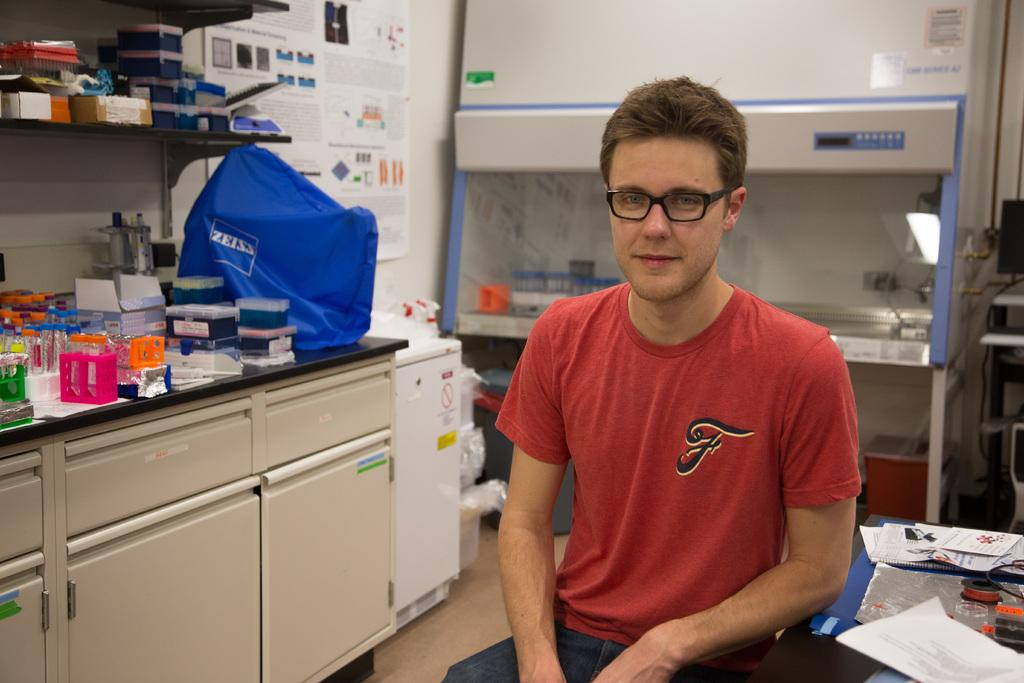<image>
Offer a succinct explanation of the picture presented. A man sitting in a lab with a red shirt and a "F" on the shirt. 